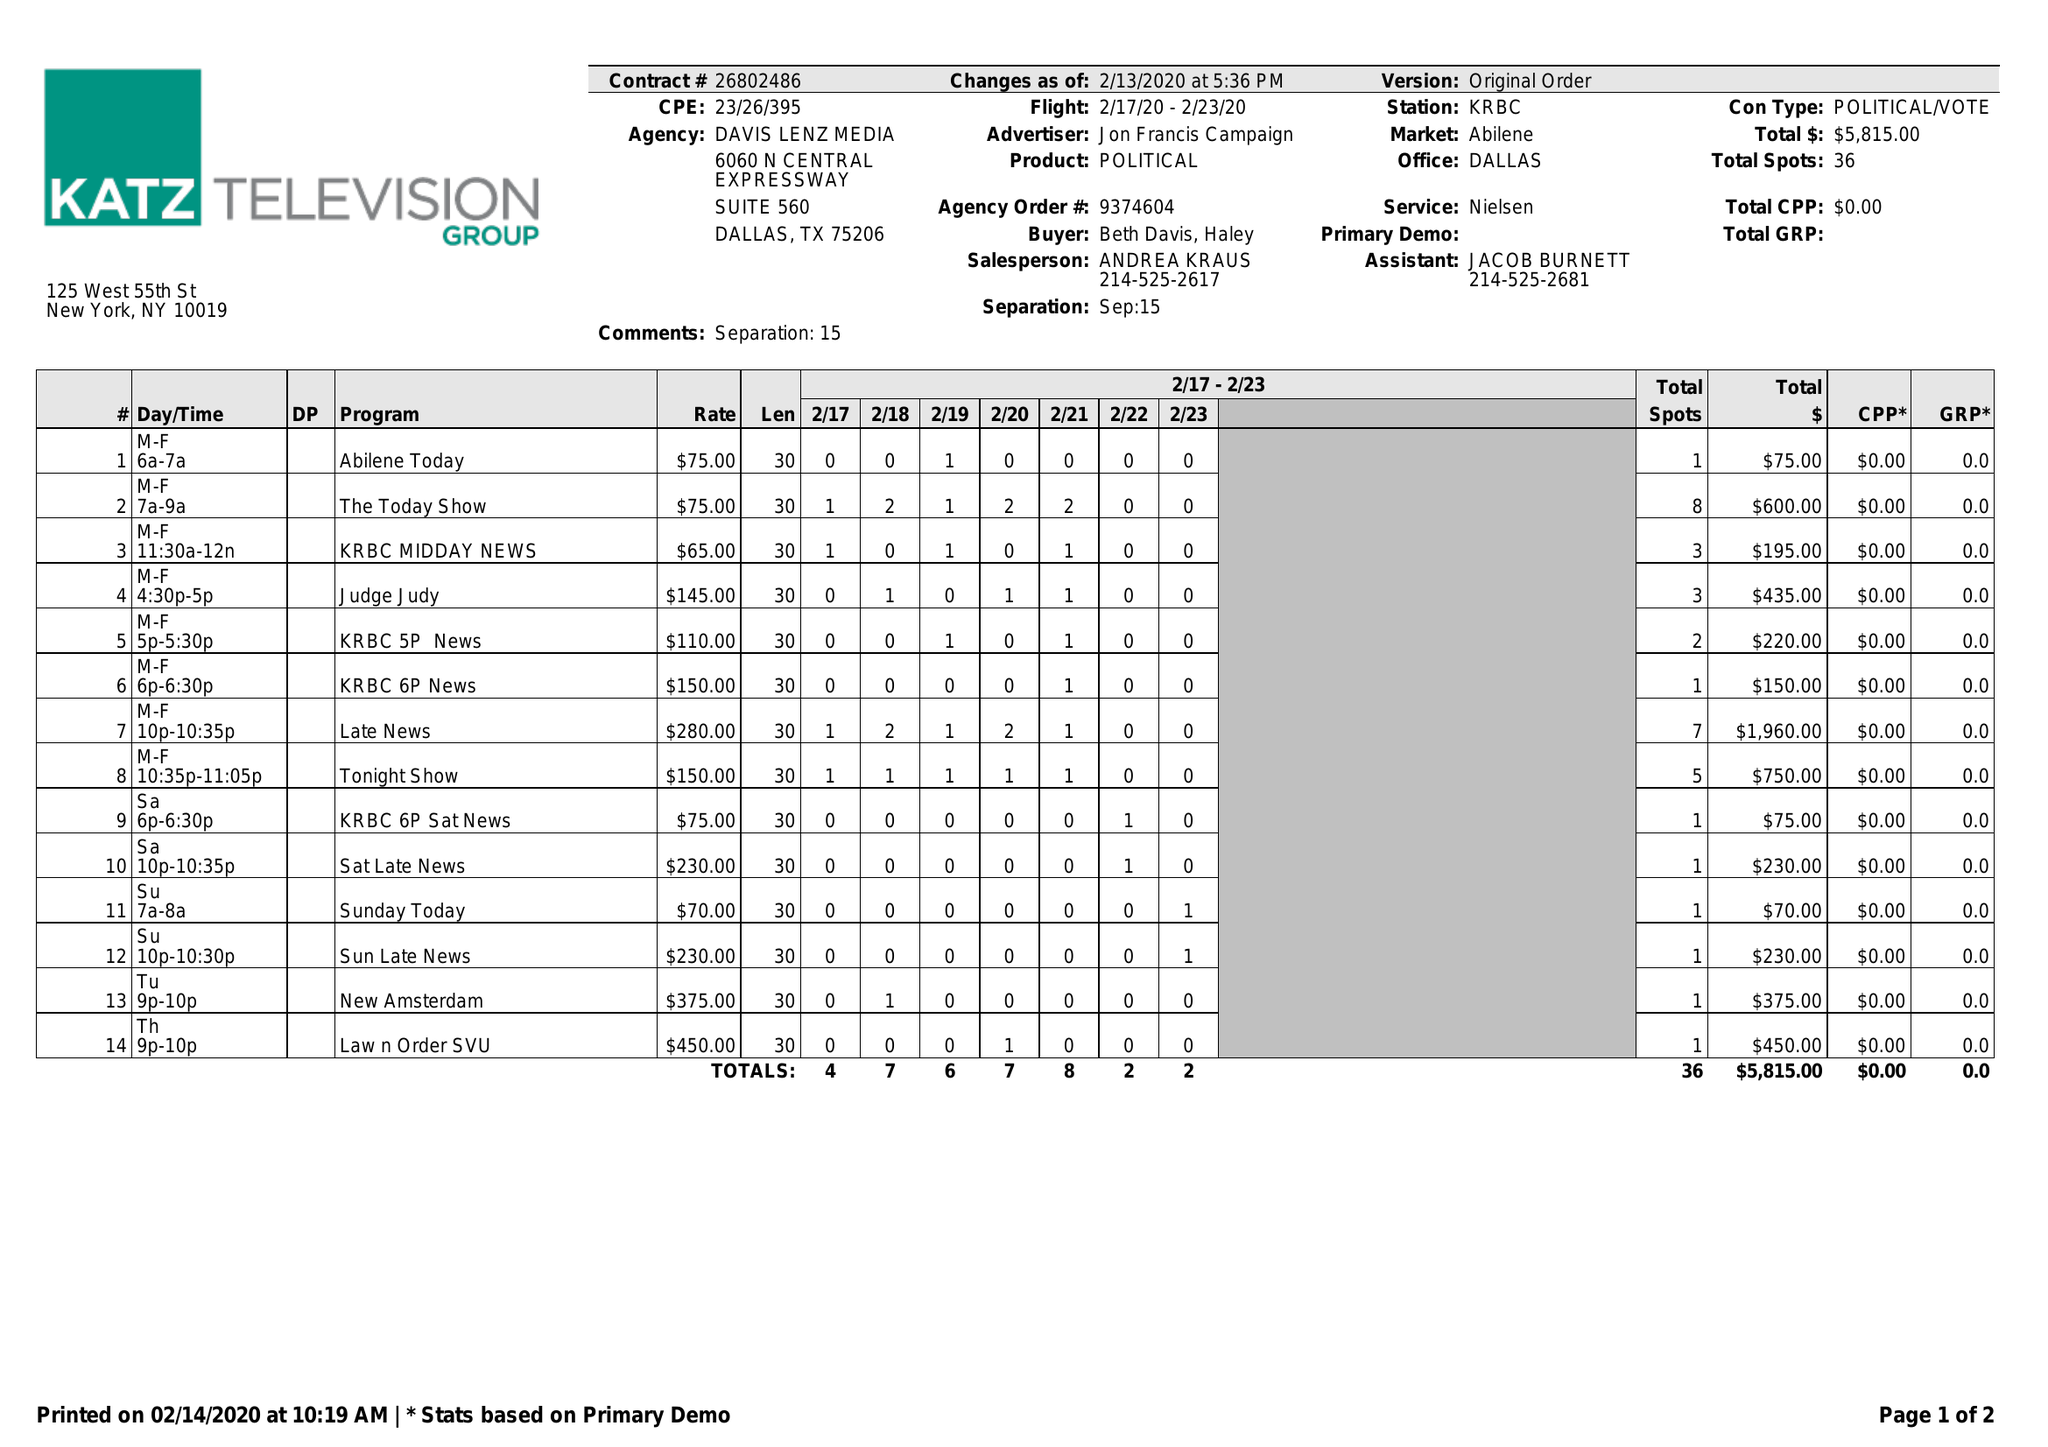What is the value for the contract_num?
Answer the question using a single word or phrase. 26802486 